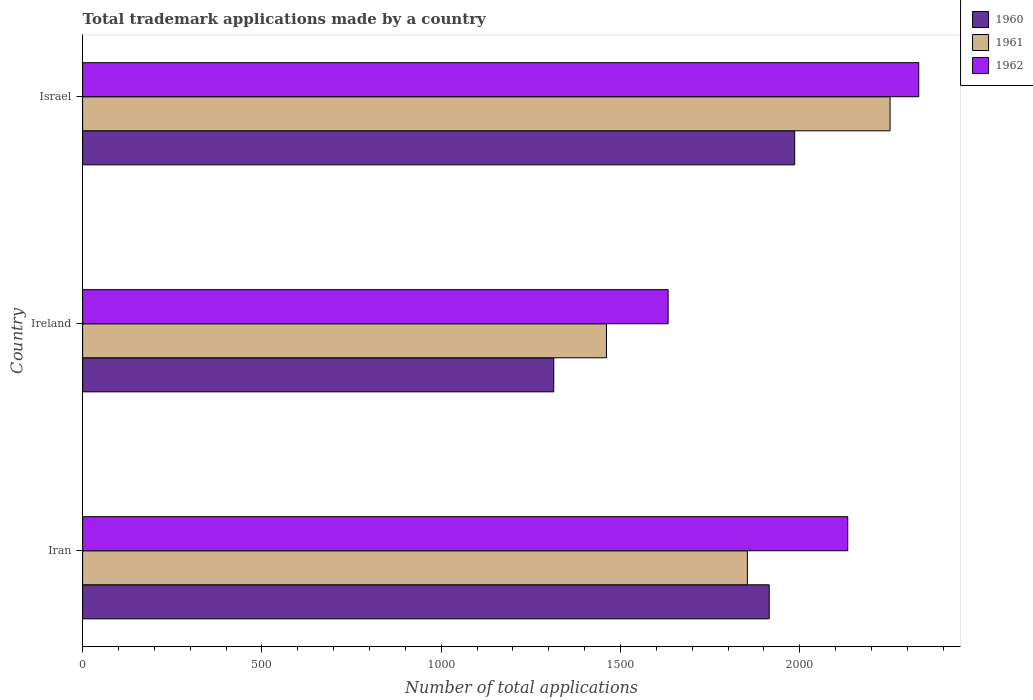How many different coloured bars are there?
Keep it short and to the point. 3. Are the number of bars per tick equal to the number of legend labels?
Offer a very short reply. Yes. How many bars are there on the 3rd tick from the bottom?
Provide a short and direct response. 3. What is the label of the 3rd group of bars from the top?
Provide a short and direct response. Iran. In how many cases, is the number of bars for a given country not equal to the number of legend labels?
Offer a very short reply. 0. What is the number of applications made by in 1960 in Ireland?
Offer a very short reply. 1314. Across all countries, what is the maximum number of applications made by in 1962?
Ensure brevity in your answer.  2332. Across all countries, what is the minimum number of applications made by in 1960?
Provide a succinct answer. 1314. In which country was the number of applications made by in 1961 minimum?
Offer a terse response. Ireland. What is the total number of applications made by in 1962 in the graph?
Your response must be concise. 6099. What is the difference between the number of applications made by in 1960 in Iran and that in Ireland?
Provide a succinct answer. 601. What is the difference between the number of applications made by in 1960 in Israel and the number of applications made by in 1962 in Ireland?
Offer a terse response. 353. What is the average number of applications made by in 1961 per country?
Make the answer very short. 1855.67. What is the difference between the number of applications made by in 1962 and number of applications made by in 1960 in Israel?
Offer a very short reply. 346. In how many countries, is the number of applications made by in 1962 greater than 1000 ?
Ensure brevity in your answer.  3. What is the ratio of the number of applications made by in 1962 in Ireland to that in Israel?
Provide a short and direct response. 0.7. Is the number of applications made by in 1962 in Ireland less than that in Israel?
Give a very brief answer. Yes. Is the difference between the number of applications made by in 1962 in Iran and Ireland greater than the difference between the number of applications made by in 1960 in Iran and Ireland?
Your answer should be compact. No. What is the difference between the highest and the second highest number of applications made by in 1961?
Ensure brevity in your answer.  398. What is the difference between the highest and the lowest number of applications made by in 1961?
Offer a very short reply. 791. In how many countries, is the number of applications made by in 1962 greater than the average number of applications made by in 1962 taken over all countries?
Offer a terse response. 2. What does the 1st bar from the bottom in Ireland represents?
Keep it short and to the point. 1960. Are the values on the major ticks of X-axis written in scientific E-notation?
Keep it short and to the point. No. Does the graph contain any zero values?
Offer a terse response. No. How are the legend labels stacked?
Ensure brevity in your answer.  Vertical. What is the title of the graph?
Provide a succinct answer. Total trademark applications made by a country. Does "1966" appear as one of the legend labels in the graph?
Give a very brief answer. No. What is the label or title of the X-axis?
Make the answer very short. Number of total applications. What is the Number of total applications of 1960 in Iran?
Your answer should be very brief. 1915. What is the Number of total applications in 1961 in Iran?
Keep it short and to the point. 1854. What is the Number of total applications of 1962 in Iran?
Give a very brief answer. 2134. What is the Number of total applications of 1960 in Ireland?
Offer a terse response. 1314. What is the Number of total applications of 1961 in Ireland?
Offer a very short reply. 1461. What is the Number of total applications in 1962 in Ireland?
Make the answer very short. 1633. What is the Number of total applications in 1960 in Israel?
Make the answer very short. 1986. What is the Number of total applications in 1961 in Israel?
Provide a succinct answer. 2252. What is the Number of total applications of 1962 in Israel?
Ensure brevity in your answer.  2332. Across all countries, what is the maximum Number of total applications in 1960?
Offer a terse response. 1986. Across all countries, what is the maximum Number of total applications of 1961?
Offer a very short reply. 2252. Across all countries, what is the maximum Number of total applications in 1962?
Your answer should be very brief. 2332. Across all countries, what is the minimum Number of total applications of 1960?
Your response must be concise. 1314. Across all countries, what is the minimum Number of total applications in 1961?
Offer a terse response. 1461. Across all countries, what is the minimum Number of total applications in 1962?
Provide a short and direct response. 1633. What is the total Number of total applications of 1960 in the graph?
Offer a very short reply. 5215. What is the total Number of total applications in 1961 in the graph?
Ensure brevity in your answer.  5567. What is the total Number of total applications of 1962 in the graph?
Offer a very short reply. 6099. What is the difference between the Number of total applications in 1960 in Iran and that in Ireland?
Ensure brevity in your answer.  601. What is the difference between the Number of total applications of 1961 in Iran and that in Ireland?
Make the answer very short. 393. What is the difference between the Number of total applications of 1962 in Iran and that in Ireland?
Your response must be concise. 501. What is the difference between the Number of total applications in 1960 in Iran and that in Israel?
Your answer should be very brief. -71. What is the difference between the Number of total applications of 1961 in Iran and that in Israel?
Give a very brief answer. -398. What is the difference between the Number of total applications of 1962 in Iran and that in Israel?
Give a very brief answer. -198. What is the difference between the Number of total applications in 1960 in Ireland and that in Israel?
Offer a very short reply. -672. What is the difference between the Number of total applications of 1961 in Ireland and that in Israel?
Make the answer very short. -791. What is the difference between the Number of total applications in 1962 in Ireland and that in Israel?
Provide a short and direct response. -699. What is the difference between the Number of total applications in 1960 in Iran and the Number of total applications in 1961 in Ireland?
Provide a short and direct response. 454. What is the difference between the Number of total applications of 1960 in Iran and the Number of total applications of 1962 in Ireland?
Provide a short and direct response. 282. What is the difference between the Number of total applications in 1961 in Iran and the Number of total applications in 1962 in Ireland?
Offer a very short reply. 221. What is the difference between the Number of total applications in 1960 in Iran and the Number of total applications in 1961 in Israel?
Offer a terse response. -337. What is the difference between the Number of total applications in 1960 in Iran and the Number of total applications in 1962 in Israel?
Your response must be concise. -417. What is the difference between the Number of total applications of 1961 in Iran and the Number of total applications of 1962 in Israel?
Your answer should be compact. -478. What is the difference between the Number of total applications of 1960 in Ireland and the Number of total applications of 1961 in Israel?
Your response must be concise. -938. What is the difference between the Number of total applications in 1960 in Ireland and the Number of total applications in 1962 in Israel?
Give a very brief answer. -1018. What is the difference between the Number of total applications of 1961 in Ireland and the Number of total applications of 1962 in Israel?
Offer a very short reply. -871. What is the average Number of total applications of 1960 per country?
Your answer should be compact. 1738.33. What is the average Number of total applications in 1961 per country?
Ensure brevity in your answer.  1855.67. What is the average Number of total applications of 1962 per country?
Offer a terse response. 2033. What is the difference between the Number of total applications of 1960 and Number of total applications of 1962 in Iran?
Make the answer very short. -219. What is the difference between the Number of total applications in 1961 and Number of total applications in 1962 in Iran?
Provide a succinct answer. -280. What is the difference between the Number of total applications of 1960 and Number of total applications of 1961 in Ireland?
Provide a succinct answer. -147. What is the difference between the Number of total applications in 1960 and Number of total applications in 1962 in Ireland?
Provide a succinct answer. -319. What is the difference between the Number of total applications of 1961 and Number of total applications of 1962 in Ireland?
Offer a very short reply. -172. What is the difference between the Number of total applications of 1960 and Number of total applications of 1961 in Israel?
Ensure brevity in your answer.  -266. What is the difference between the Number of total applications in 1960 and Number of total applications in 1962 in Israel?
Your answer should be compact. -346. What is the difference between the Number of total applications in 1961 and Number of total applications in 1962 in Israel?
Provide a short and direct response. -80. What is the ratio of the Number of total applications of 1960 in Iran to that in Ireland?
Provide a succinct answer. 1.46. What is the ratio of the Number of total applications of 1961 in Iran to that in Ireland?
Keep it short and to the point. 1.27. What is the ratio of the Number of total applications in 1962 in Iran to that in Ireland?
Your response must be concise. 1.31. What is the ratio of the Number of total applications of 1960 in Iran to that in Israel?
Make the answer very short. 0.96. What is the ratio of the Number of total applications in 1961 in Iran to that in Israel?
Ensure brevity in your answer.  0.82. What is the ratio of the Number of total applications of 1962 in Iran to that in Israel?
Keep it short and to the point. 0.92. What is the ratio of the Number of total applications in 1960 in Ireland to that in Israel?
Keep it short and to the point. 0.66. What is the ratio of the Number of total applications in 1961 in Ireland to that in Israel?
Give a very brief answer. 0.65. What is the ratio of the Number of total applications in 1962 in Ireland to that in Israel?
Make the answer very short. 0.7. What is the difference between the highest and the second highest Number of total applications in 1960?
Your response must be concise. 71. What is the difference between the highest and the second highest Number of total applications of 1961?
Your answer should be very brief. 398. What is the difference between the highest and the second highest Number of total applications in 1962?
Ensure brevity in your answer.  198. What is the difference between the highest and the lowest Number of total applications of 1960?
Make the answer very short. 672. What is the difference between the highest and the lowest Number of total applications of 1961?
Your response must be concise. 791. What is the difference between the highest and the lowest Number of total applications in 1962?
Give a very brief answer. 699. 